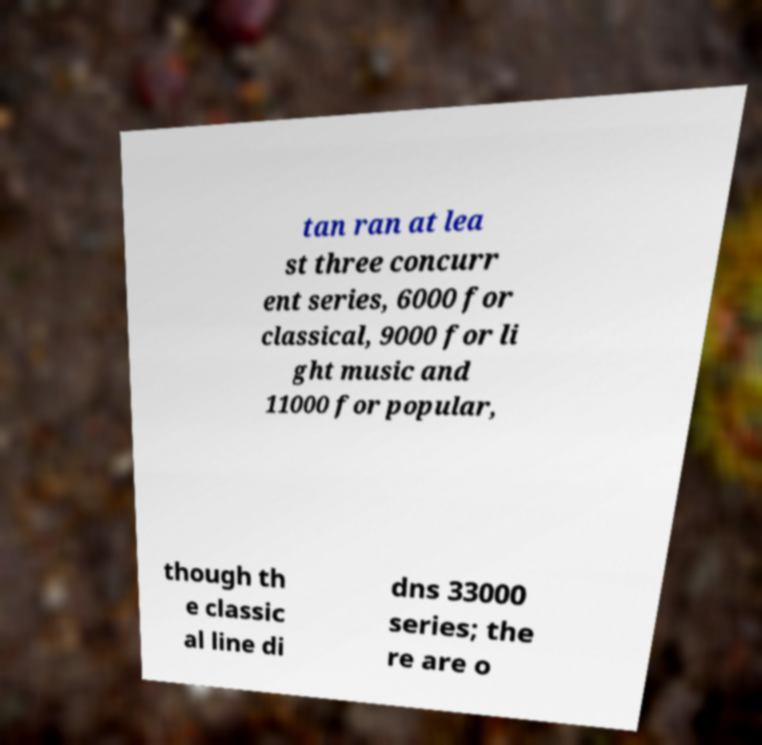There's text embedded in this image that I need extracted. Can you transcribe it verbatim? tan ran at lea st three concurr ent series, 6000 for classical, 9000 for li ght music and 11000 for popular, though th e classic al line di dns 33000 series; the re are o 